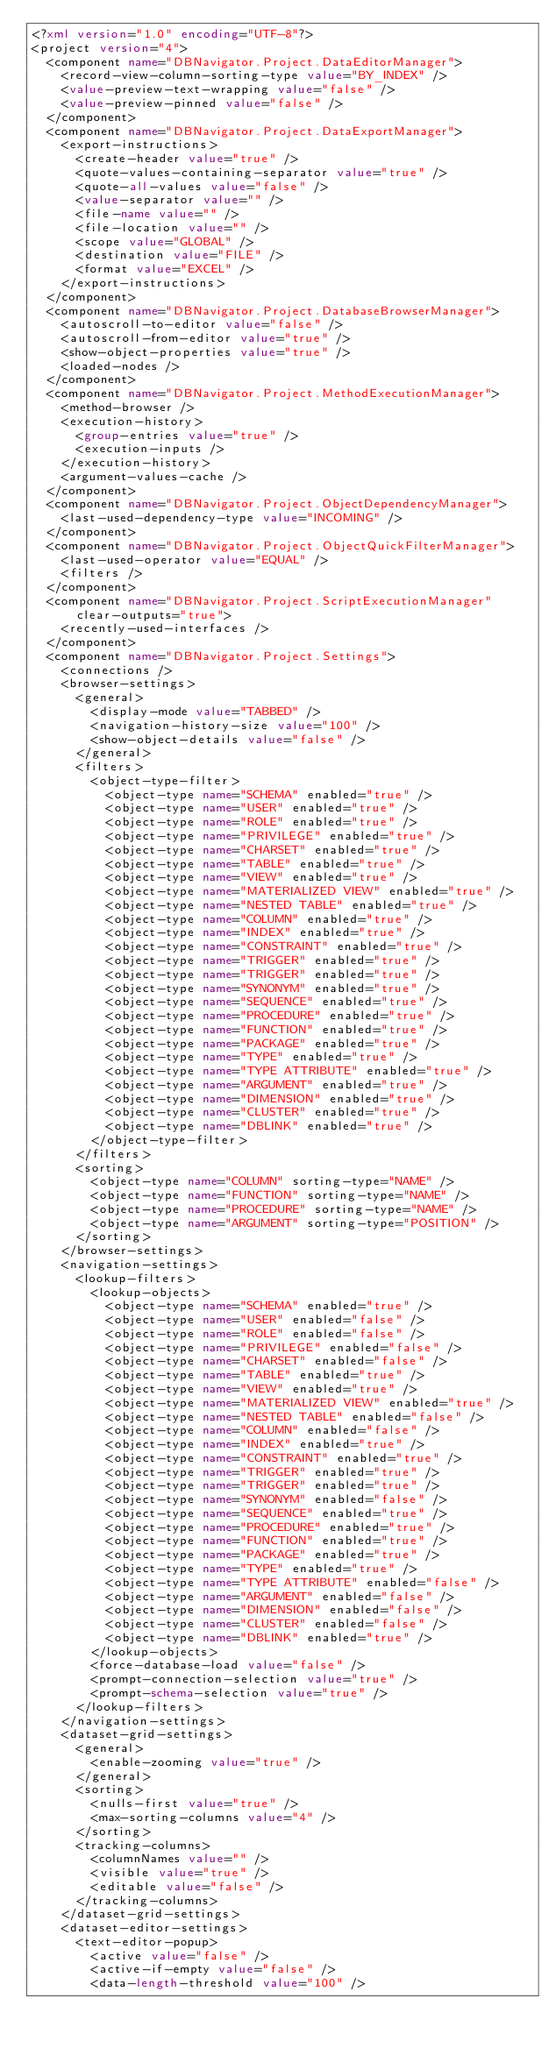<code> <loc_0><loc_0><loc_500><loc_500><_XML_><?xml version="1.0" encoding="UTF-8"?>
<project version="4">
  <component name="DBNavigator.Project.DataEditorManager">
    <record-view-column-sorting-type value="BY_INDEX" />
    <value-preview-text-wrapping value="false" />
    <value-preview-pinned value="false" />
  </component>
  <component name="DBNavigator.Project.DataExportManager">
    <export-instructions>
      <create-header value="true" />
      <quote-values-containing-separator value="true" />
      <quote-all-values value="false" />
      <value-separator value="" />
      <file-name value="" />
      <file-location value="" />
      <scope value="GLOBAL" />
      <destination value="FILE" />
      <format value="EXCEL" />
    </export-instructions>
  </component>
  <component name="DBNavigator.Project.DatabaseBrowserManager">
    <autoscroll-to-editor value="false" />
    <autoscroll-from-editor value="true" />
    <show-object-properties value="true" />
    <loaded-nodes />
  </component>
  <component name="DBNavigator.Project.MethodExecutionManager">
    <method-browser />
    <execution-history>
      <group-entries value="true" />
      <execution-inputs />
    </execution-history>
    <argument-values-cache />
  </component>
  <component name="DBNavigator.Project.ObjectDependencyManager">
    <last-used-dependency-type value="INCOMING" />
  </component>
  <component name="DBNavigator.Project.ObjectQuickFilterManager">
    <last-used-operator value="EQUAL" />
    <filters />
  </component>
  <component name="DBNavigator.Project.ScriptExecutionManager" clear-outputs="true">
    <recently-used-interfaces />
  </component>
  <component name="DBNavigator.Project.Settings">
    <connections />
    <browser-settings>
      <general>
        <display-mode value="TABBED" />
        <navigation-history-size value="100" />
        <show-object-details value="false" />
      </general>
      <filters>
        <object-type-filter>
          <object-type name="SCHEMA" enabled="true" />
          <object-type name="USER" enabled="true" />
          <object-type name="ROLE" enabled="true" />
          <object-type name="PRIVILEGE" enabled="true" />
          <object-type name="CHARSET" enabled="true" />
          <object-type name="TABLE" enabled="true" />
          <object-type name="VIEW" enabled="true" />
          <object-type name="MATERIALIZED VIEW" enabled="true" />
          <object-type name="NESTED TABLE" enabled="true" />
          <object-type name="COLUMN" enabled="true" />
          <object-type name="INDEX" enabled="true" />
          <object-type name="CONSTRAINT" enabled="true" />
          <object-type name="TRIGGER" enabled="true" />
          <object-type name="TRIGGER" enabled="true" />
          <object-type name="SYNONYM" enabled="true" />
          <object-type name="SEQUENCE" enabled="true" />
          <object-type name="PROCEDURE" enabled="true" />
          <object-type name="FUNCTION" enabled="true" />
          <object-type name="PACKAGE" enabled="true" />
          <object-type name="TYPE" enabled="true" />
          <object-type name="TYPE ATTRIBUTE" enabled="true" />
          <object-type name="ARGUMENT" enabled="true" />
          <object-type name="DIMENSION" enabled="true" />
          <object-type name="CLUSTER" enabled="true" />
          <object-type name="DBLINK" enabled="true" />
        </object-type-filter>
      </filters>
      <sorting>
        <object-type name="COLUMN" sorting-type="NAME" />
        <object-type name="FUNCTION" sorting-type="NAME" />
        <object-type name="PROCEDURE" sorting-type="NAME" />
        <object-type name="ARGUMENT" sorting-type="POSITION" />
      </sorting>
    </browser-settings>
    <navigation-settings>
      <lookup-filters>
        <lookup-objects>
          <object-type name="SCHEMA" enabled="true" />
          <object-type name="USER" enabled="false" />
          <object-type name="ROLE" enabled="false" />
          <object-type name="PRIVILEGE" enabled="false" />
          <object-type name="CHARSET" enabled="false" />
          <object-type name="TABLE" enabled="true" />
          <object-type name="VIEW" enabled="true" />
          <object-type name="MATERIALIZED VIEW" enabled="true" />
          <object-type name="NESTED TABLE" enabled="false" />
          <object-type name="COLUMN" enabled="false" />
          <object-type name="INDEX" enabled="true" />
          <object-type name="CONSTRAINT" enabled="true" />
          <object-type name="TRIGGER" enabled="true" />
          <object-type name="TRIGGER" enabled="true" />
          <object-type name="SYNONYM" enabled="false" />
          <object-type name="SEQUENCE" enabled="true" />
          <object-type name="PROCEDURE" enabled="true" />
          <object-type name="FUNCTION" enabled="true" />
          <object-type name="PACKAGE" enabled="true" />
          <object-type name="TYPE" enabled="true" />
          <object-type name="TYPE ATTRIBUTE" enabled="false" />
          <object-type name="ARGUMENT" enabled="false" />
          <object-type name="DIMENSION" enabled="false" />
          <object-type name="CLUSTER" enabled="false" />
          <object-type name="DBLINK" enabled="true" />
        </lookup-objects>
        <force-database-load value="false" />
        <prompt-connection-selection value="true" />
        <prompt-schema-selection value="true" />
      </lookup-filters>
    </navigation-settings>
    <dataset-grid-settings>
      <general>
        <enable-zooming value="true" />
      </general>
      <sorting>
        <nulls-first value="true" />
        <max-sorting-columns value="4" />
      </sorting>
      <tracking-columns>
        <columnNames value="" />
        <visible value="true" />
        <editable value="false" />
      </tracking-columns>
    </dataset-grid-settings>
    <dataset-editor-settings>
      <text-editor-popup>
        <active value="false" />
        <active-if-empty value="false" />
        <data-length-threshold value="100" /></code> 